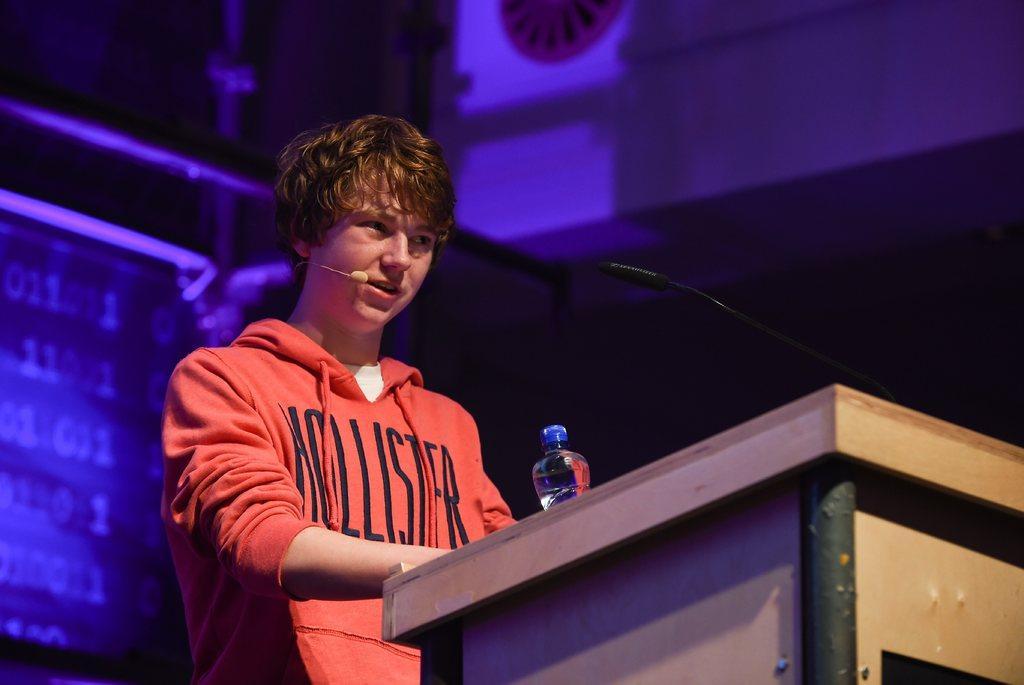In one or two sentences, can you explain what this image depicts? In this image we can see a person wearing red color T-shirt, attached a microphone to his ear standing behind the wooden podium on which there is water bottle and microphone and in the background of the image there is some blue color light which is falling on some screens and sheets. 